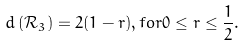Convert formula to latex. <formula><loc_0><loc_0><loc_500><loc_500>d \left ( \mathcal { R } _ { 3 } \right ) = 2 ( 1 - r ) , f o r 0 \leq r \leq \frac { 1 } { 2 } .</formula> 